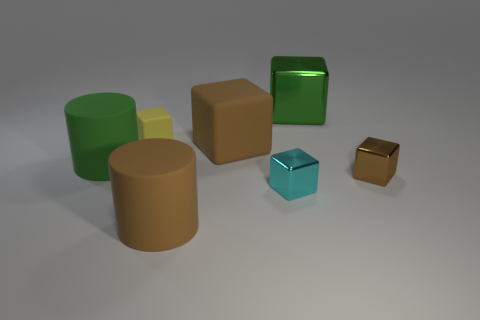Add 2 large red rubber balls. How many objects exist? 9 Subtract all small yellow rubber cubes. How many cubes are left? 4 Subtract all cylinders. How many objects are left? 5 Subtract all yellow blocks. How many blocks are left? 4 Add 1 large brown cylinders. How many large brown cylinders are left? 2 Add 6 tiny purple things. How many tiny purple things exist? 6 Subtract 1 brown cylinders. How many objects are left? 6 Subtract 1 cylinders. How many cylinders are left? 1 Subtract all blue cubes. Subtract all purple spheres. How many cubes are left? 5 Subtract all red blocks. How many purple cylinders are left? 0 